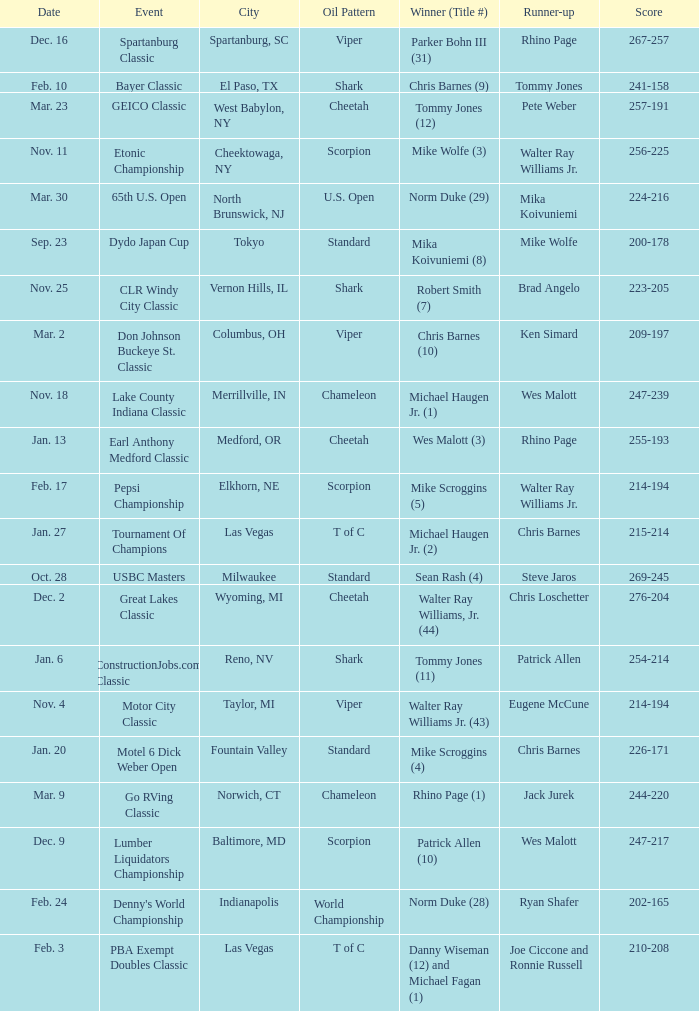Name the Date when has  robert smith (7)? Nov. 25. 